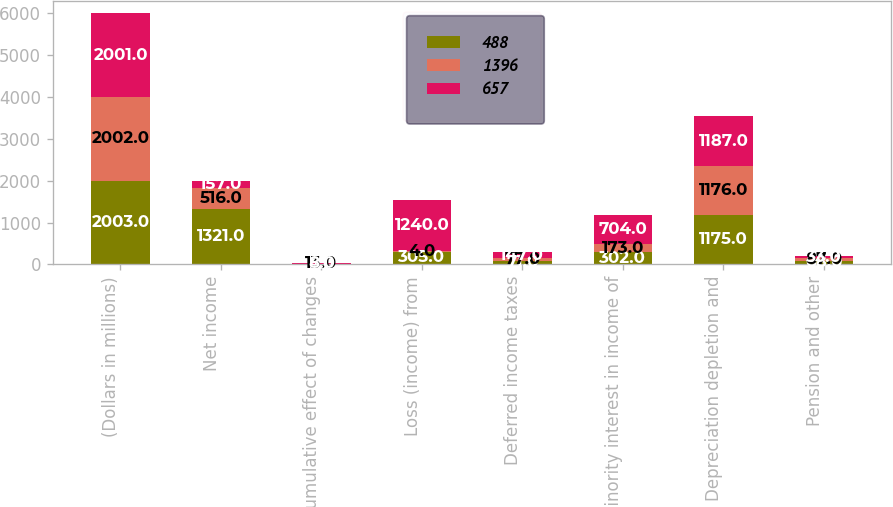Convert chart to OTSL. <chart><loc_0><loc_0><loc_500><loc_500><stacked_bar_chart><ecel><fcel>(Dollars in millions)<fcel>Net income<fcel>Cumulative effect of changes<fcel>Loss (income) from<fcel>Deferred income taxes<fcel>Minority interest in income of<fcel>Depreciation depletion and<fcel>Pension and other<nl><fcel>488<fcel>2003<fcel>1321<fcel>4<fcel>305<fcel>71<fcel>302<fcel>1175<fcel>68<nl><fcel>1396<fcel>2002<fcel>516<fcel>13<fcel>4<fcel>77<fcel>173<fcel>1176<fcel>87<nl><fcel>657<fcel>2001<fcel>157<fcel>8<fcel>1240<fcel>147<fcel>704<fcel>1187<fcel>33<nl></chart> 